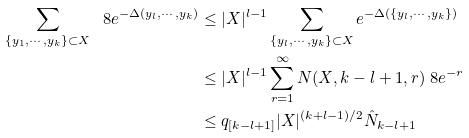<formula> <loc_0><loc_0><loc_500><loc_500>\sum _ { \{ y _ { 1 } , \cdots , y _ { k } \} \subset X } \ 8 e ^ { - \Delta ( y _ { l } , \cdots , y _ { k } ) } & \leq | X | ^ { l - 1 } \sum _ { \{ y _ { l } , \cdots , y _ { k } \} \subset X } e ^ { - \Delta ( \{ y _ { l } , \cdots , y _ { k } \} ) } \\ & \leq | X | ^ { l - 1 } \sum _ { r = 1 } ^ { \infty } N ( X , k - l + 1 , r ) \ 8 e ^ { - r } \\ & \leq q _ { [ k - l + 1 ] } | X | ^ { ( k + l - 1 ) / 2 } \hat { N } _ { k - l + 1 }</formula> 